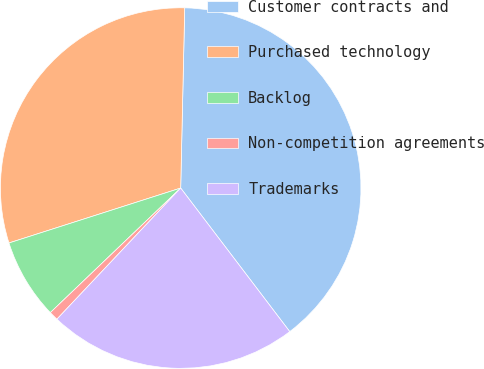<chart> <loc_0><loc_0><loc_500><loc_500><pie_chart><fcel>Customer contracts and<fcel>Purchased technology<fcel>Backlog<fcel>Non-competition agreements<fcel>Trademarks<nl><fcel>39.3%<fcel>30.28%<fcel>7.21%<fcel>0.82%<fcel>22.38%<nl></chart> 